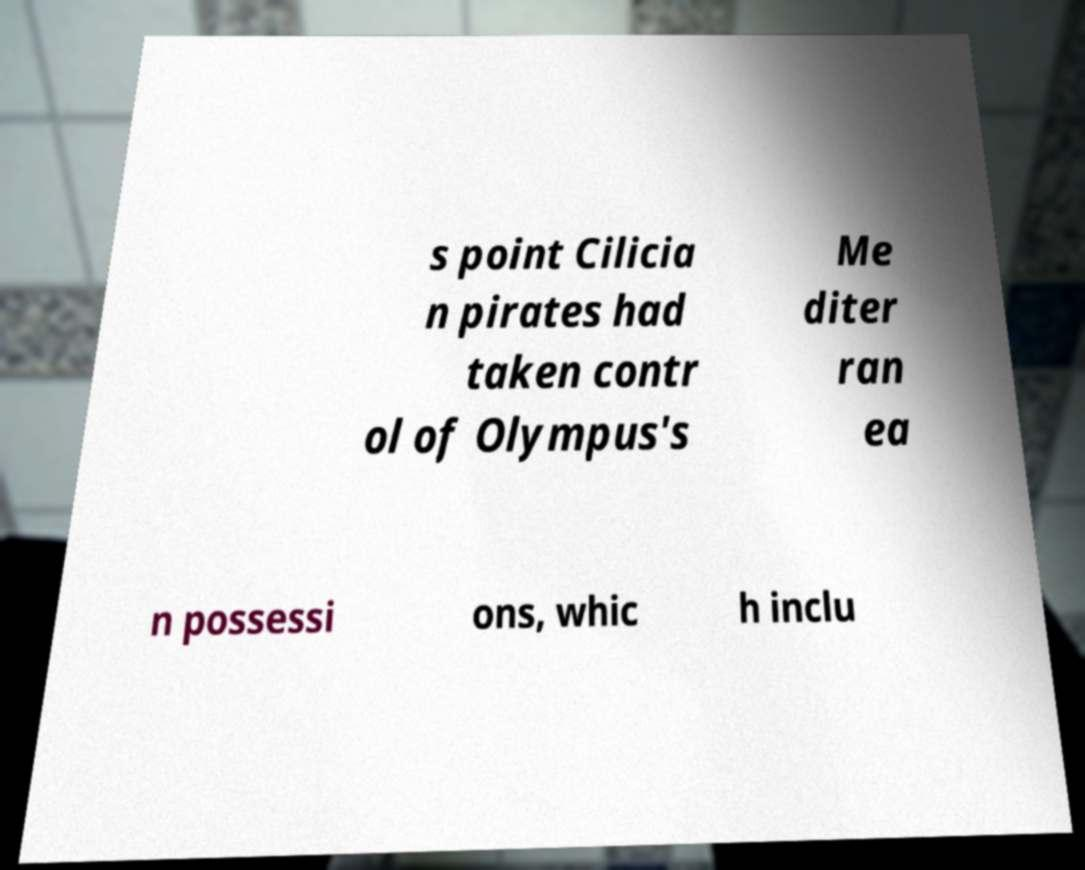There's text embedded in this image that I need extracted. Can you transcribe it verbatim? s point Cilicia n pirates had taken contr ol of Olympus's Me diter ran ea n possessi ons, whic h inclu 